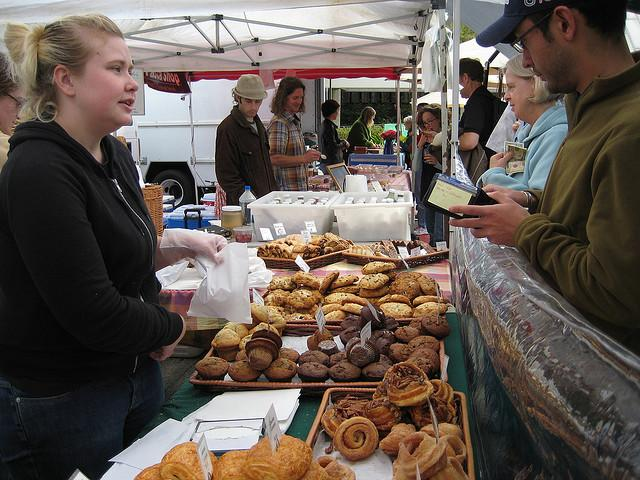Why is the woman on the left standing behind the table of pastries? Please explain your reasoning. she's selling. The man on the opposite side is taking money out of his wallet to buy the food from the woman, while she is holding the bag of pastries to give to the man after he pays. 